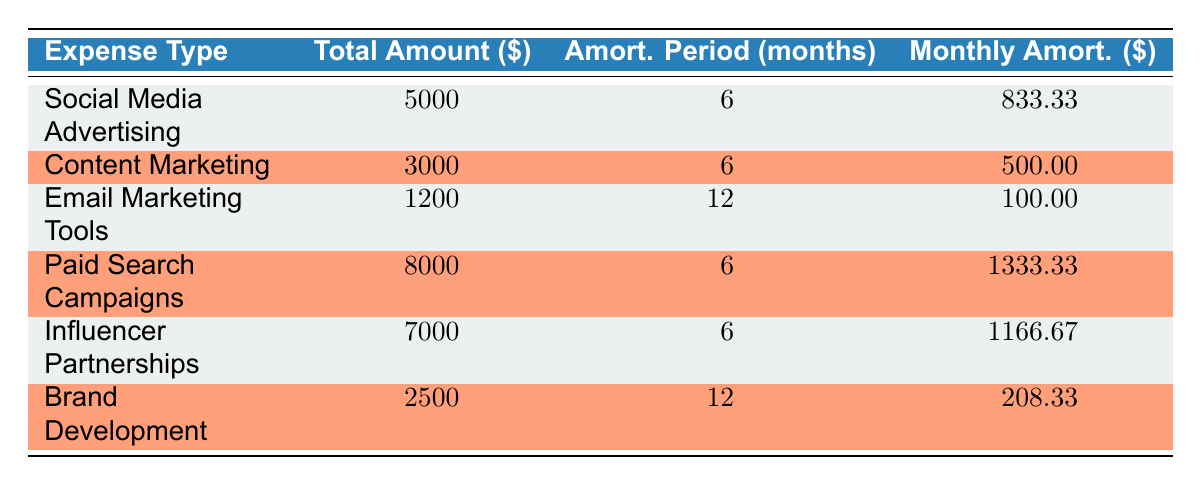What is the total amount spent on Social Media Advertising? The table shows that the total amount for Social Media Advertising is listed directly under the "Total Amount" column as 5000.
Answer: 5000 How long is the amortization period for Email Marketing Tools? Looking at the "Amort. Period (months)" column for Email Marketing Tools, it states that the amortization period is 12 months.
Answer: 12 months What is the total cost of Content Marketing and Brand Development combined? The total amount for Content Marketing is 3000, and for Brand Development, it is 2500. Adding these gives 3000 + 2500 = 5500.
Answer: 5500 Which marketing expense has the highest monthly amortization? Comparing the "Monthly Amort." column, Paid Search Campaigns has the highest amount, which is 1333.33.
Answer: Paid Search Campaigns Is the total amount for Influencer Partnerships greater than that for Email Marketing Tools? Influencer Partnerships has a total amount of 7000, while Email Marketing Tools has 1200. Since 7000 is greater than 1200, the statement is true.
Answer: Yes What is the average monthly amortization for all marketing expenses? To find the average, we sum the monthly amortization values: 833.33 + 500.00 + 100.00 + 1333.33 + 1166.67 + 208.33 = 3141.66. Dividing by 6 (the number of expenses) gives 3141.66 / 6 = 523.61.
Answer: 523.61 Are all marketing expenses amortized over a period of 6 months? In the table, not all expenses are amortized over 6 months; the Email Marketing Tools and Brand Development are amortized over 12 months. Therefore, the statement is false.
Answer: No What is the difference in total amount between Paid Search Campaigns and Social Media Advertising? The total amount for Paid Search Campaigns is 8000, and for Social Media Advertising, it is 5000. The difference is 8000 - 5000 = 3000.
Answer: 3000 